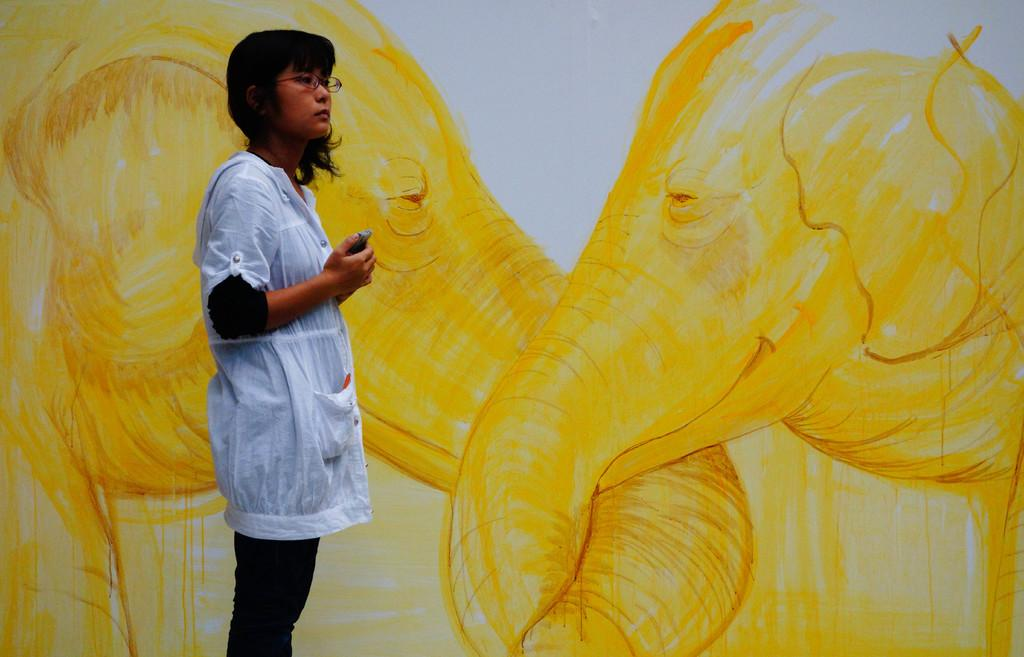What is on the wall in the image? There is an art piece on the wall in the image. What can be seen in the center of the image? There is a person standing in the middle of the image. What is the person wearing in the image? The person is wearing clothes in the image. Can you see an owl in the image? There is no owl present in the image. 